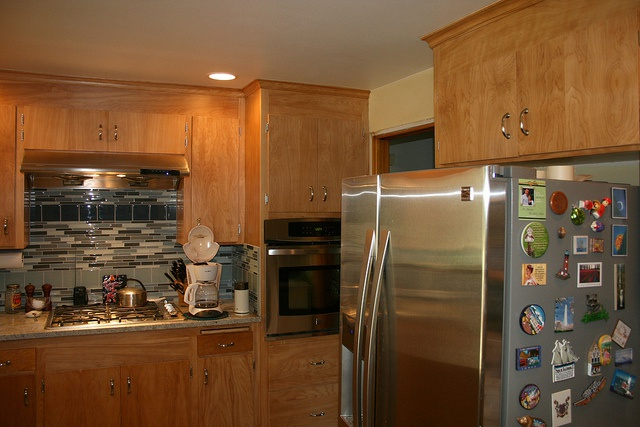Describe the objects in this image and their specific colors. I can see refrigerator in maroon, black, and gray tones and oven in maroon, black, and gray tones in this image. 